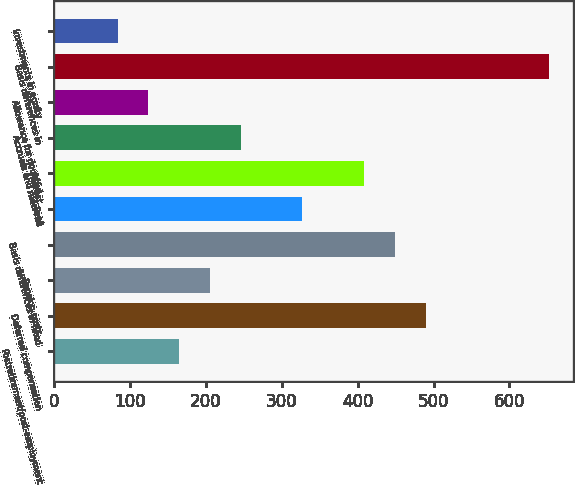Convert chart. <chart><loc_0><loc_0><loc_500><loc_500><bar_chart><fcel>Postretirement/post-employment<fcel>Deferred compensation<fcel>Pension costs<fcel>Basis differences in fixed<fcel>Rent<fcel>Interest<fcel>Accruals and reserves<fcel>Allowance for doubtful<fcel>Basis differences in<fcel>Investments in equity<nl><fcel>164.66<fcel>489.38<fcel>205.25<fcel>448.79<fcel>327.02<fcel>408.2<fcel>245.84<fcel>124.07<fcel>651.74<fcel>83.48<nl></chart> 